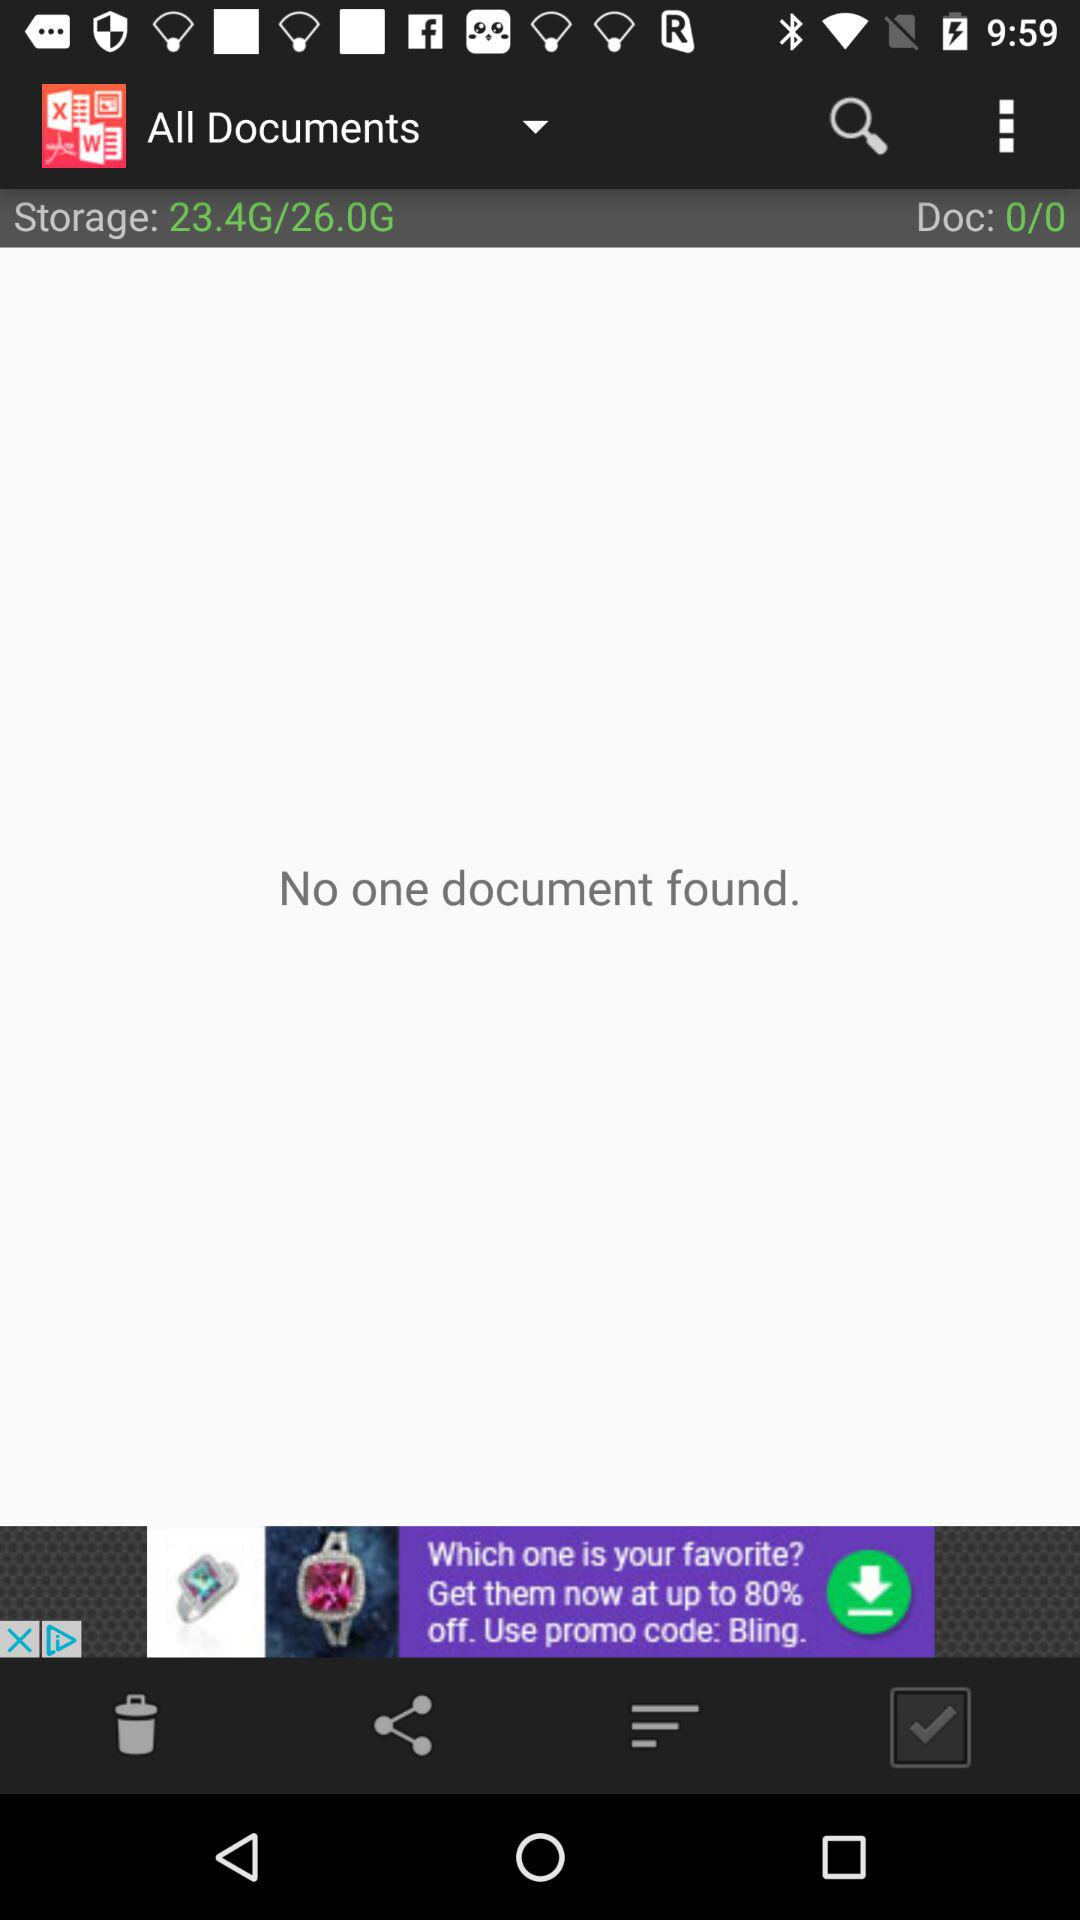How much storage is occupied? The occupied storage is 23.4 GB. 